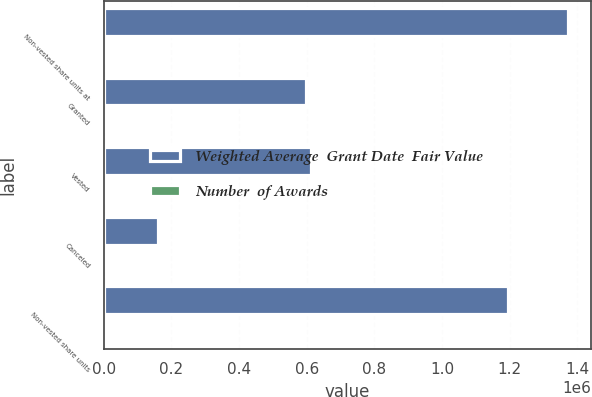<chart> <loc_0><loc_0><loc_500><loc_500><stacked_bar_chart><ecel><fcel>Non-vested share units at<fcel>Granted<fcel>Vested<fcel>Canceled<fcel>Non-vested share units<nl><fcel>Weighted Average  Grant Date  Fair Value<fcel>1.37222e+06<fcel>599163<fcel>613650<fcel>161298<fcel>1.19644e+06<nl><fcel>Number  of Awards<fcel>15.67<fcel>30.03<fcel>30.19<fcel>26<fcel>14.02<nl></chart> 